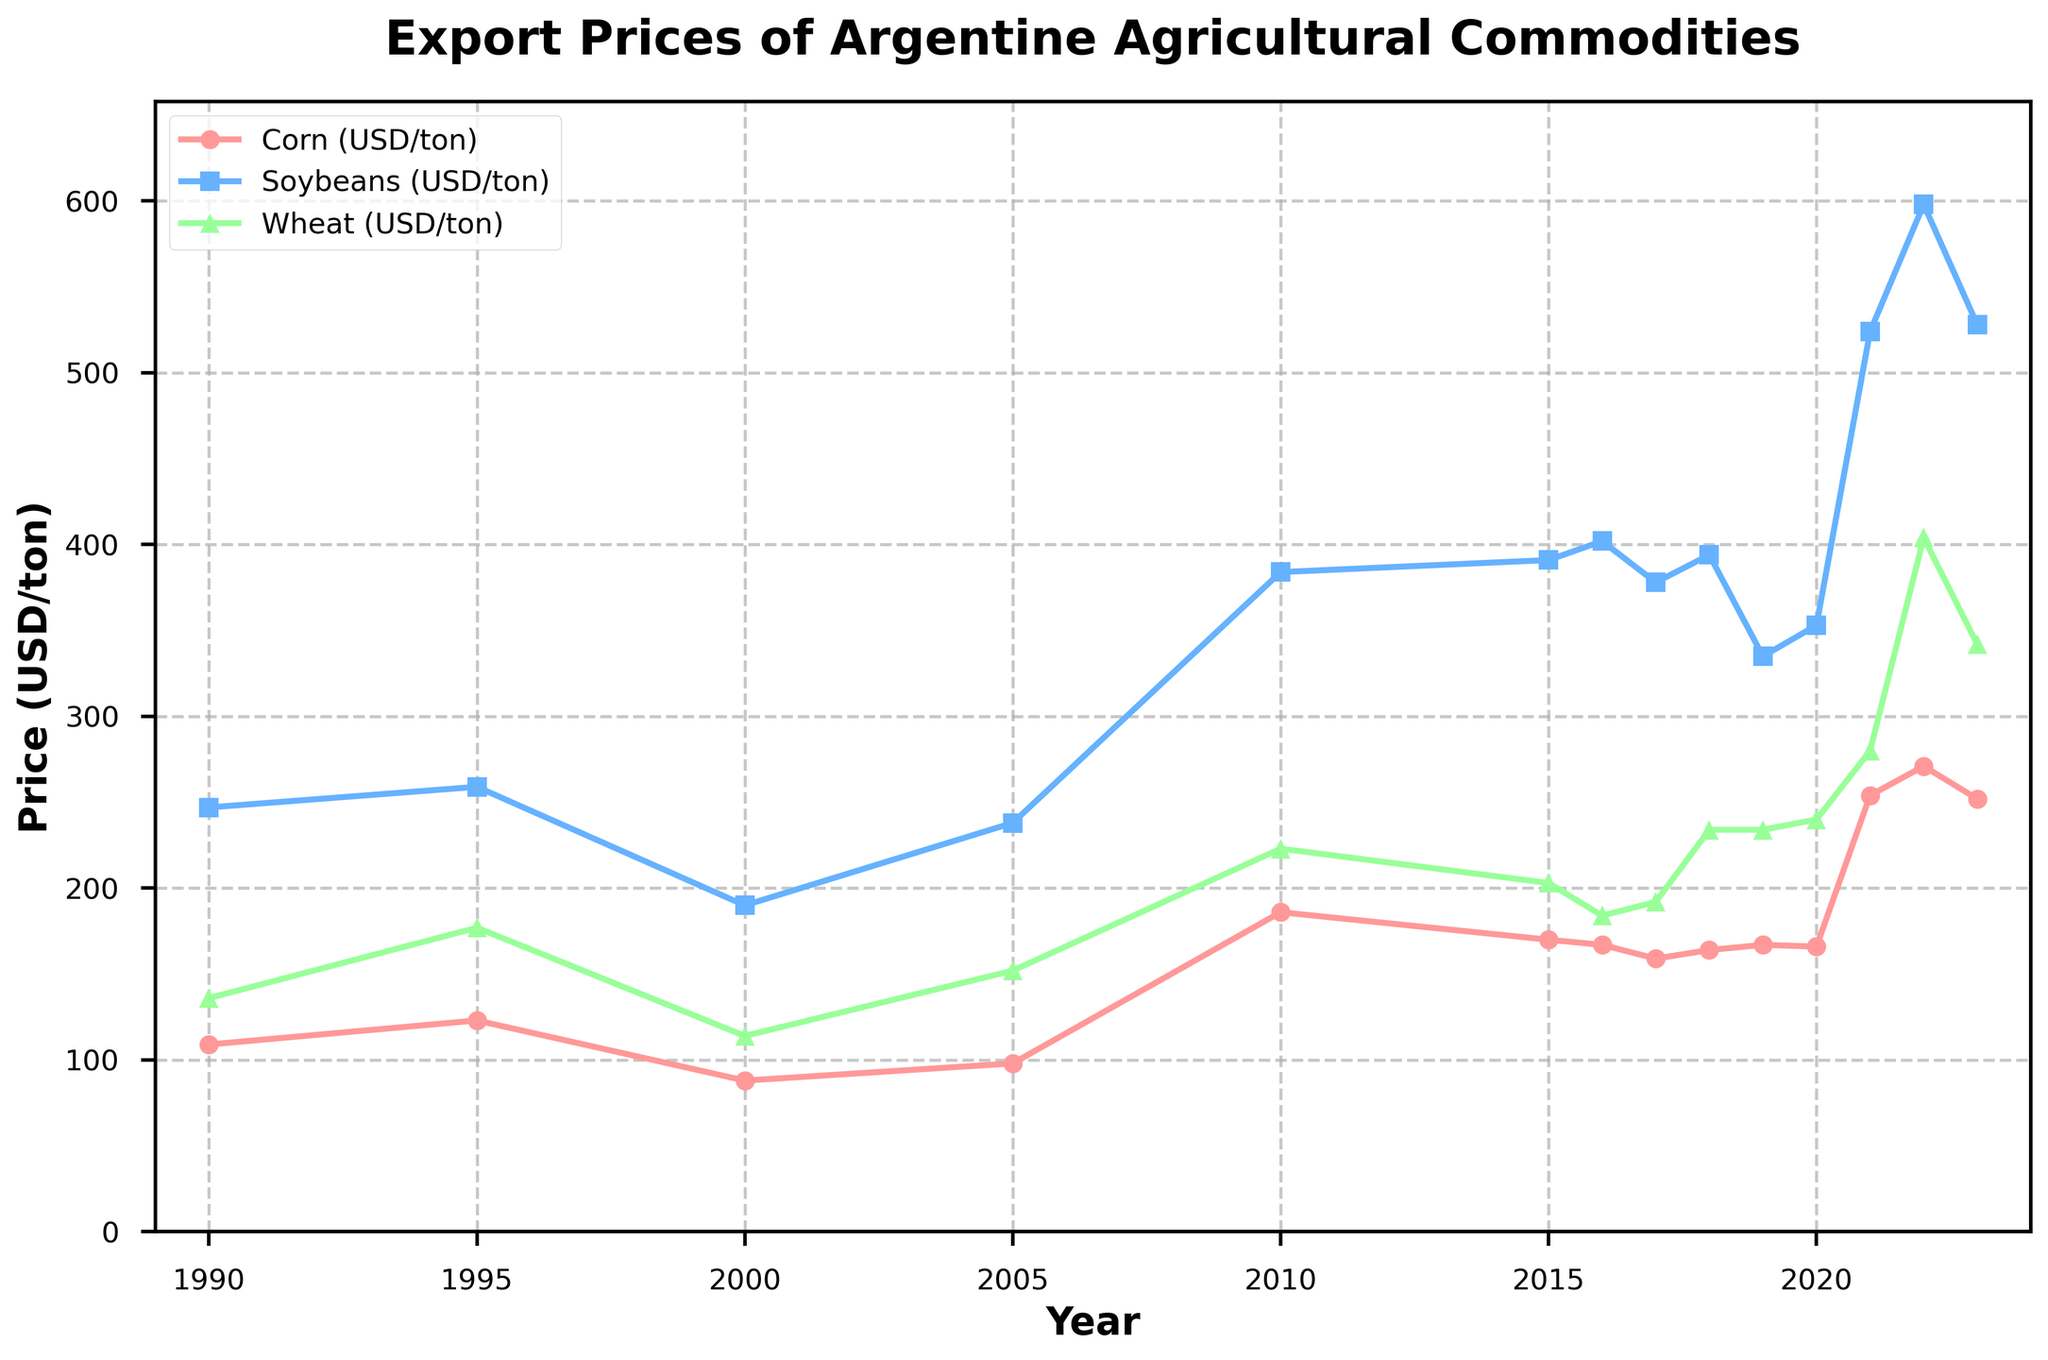What's the trend of corn prices from 1990 to 2023? The corn prices show an increasing trend with some fluctuations. Starting from USD 109/ton in 1990, the prices generally rise, hitting a peak in 2022 at USD 271/ton before slightly declining to USD 252/ton in 2023.
Answer: Increasing trend Which year had the highest soybean price, and what was the price? By observing the line representing soybean prices, the year 2022 had the highest price at USD 598/ton.
Answer: 2022, USD 598/ton In which years did the wheat price exceed USD 200/ton? Wheat prices exceeded USD 200/ton in the years 2010, 2015, 2018, 2019, 2020, 2021, 2022, and 2023. This is visually observed by comparing the wheat line crossing the 200 mark on the y-axis.
Answer: 2010, 2015, 2018, 2019, 2020, 2021, 2022, 2023 What is the average price of corn from 1990 to 2023? Sum the corn prices over the years (109 + 123 + 88 + 98 + 186 + 170 + 167 + 159 + 164 + 167 + 166 + 254 + 271 + 252) and divide by the number of years (14). The sum is 2374, and the average is 2374/14.
Answer: 169.57 USD/ton How does the price of wheat in 2023 compare to that in 2010? The price of wheat in 2023 is USD 342/ton, whereas it was USD 223/ton in 2010. To find the difference, subtract 223 from 342.
Answer: 119 USD/ton higher In what year did corn prices see the largest increase compared to the previous year? Comparing year-to-year changes in the corn prices, the largest increase occurred from 2020 (USD 166/ton) to 2021 (USD 254/ton). The difference is 88.
Answer: 2021 What was the price of soybeans in 2017, and how did it change in the next three years? The price of soybeans in 2017 was USD 378/ton. In 2018, it increased to USD 394/ton. In 2019, it decreased to USD 335/ton. In 2020, it slightly increased to USD 353/ton.
Answer: 378, +16, -59, +18 Which commodity showed the most stability in prices over the years? By observing the trends, corn prices show less fluctuation and a more stable trend compared to soybeans and wheat, which have more pronounced spikes and drops.
Answer: Corn Calculate the average price difference between soybeans and wheat in 2021. The soybean price in 2021 is USD 524/ton, and the wheat price is USD 280/ton. The difference is 524 - 280.
Answer: 244 USD/ton Which commodity had the lowest price in 1995, and what was the price? In 1995, the line representing wheat prices is the lowest among the three commodities, at USD 177/ton.
Answer: Wheat, USD 177/ton 